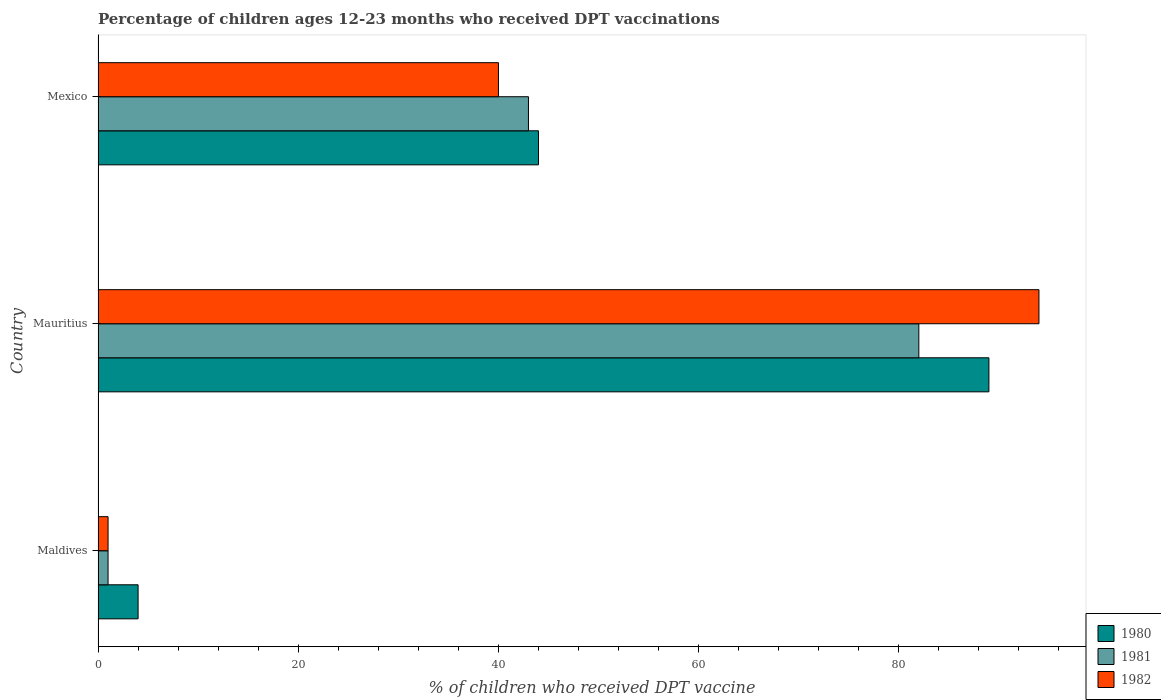How many different coloured bars are there?
Your answer should be compact. 3. How many groups of bars are there?
Keep it short and to the point. 3. Are the number of bars on each tick of the Y-axis equal?
Keep it short and to the point. Yes. How many bars are there on the 1st tick from the bottom?
Offer a terse response. 3. What is the label of the 2nd group of bars from the top?
Your response must be concise. Mauritius. What is the percentage of children who received DPT vaccination in 1980 in Mauritius?
Provide a succinct answer. 89. Across all countries, what is the minimum percentage of children who received DPT vaccination in 1982?
Your answer should be very brief. 1. In which country was the percentage of children who received DPT vaccination in 1981 maximum?
Your answer should be very brief. Mauritius. In which country was the percentage of children who received DPT vaccination in 1981 minimum?
Ensure brevity in your answer.  Maldives. What is the total percentage of children who received DPT vaccination in 1982 in the graph?
Your answer should be compact. 135. What is the difference between the percentage of children who received DPT vaccination in 1982 in Mauritius and that in Mexico?
Make the answer very short. 54. What is the difference between the percentage of children who received DPT vaccination in 1981 in Mauritius and the percentage of children who received DPT vaccination in 1982 in Maldives?
Give a very brief answer. 81. What is the average percentage of children who received DPT vaccination in 1980 per country?
Ensure brevity in your answer.  45.67. In how many countries, is the percentage of children who received DPT vaccination in 1982 greater than 52 %?
Provide a short and direct response. 1. What is the ratio of the percentage of children who received DPT vaccination in 1982 in Mauritius to that in Mexico?
Give a very brief answer. 2.35. Is the percentage of children who received DPT vaccination in 1982 in Maldives less than that in Mauritius?
Your answer should be very brief. Yes. What is the difference between the highest and the second highest percentage of children who received DPT vaccination in 1981?
Your answer should be very brief. 39. In how many countries, is the percentage of children who received DPT vaccination in 1980 greater than the average percentage of children who received DPT vaccination in 1980 taken over all countries?
Provide a short and direct response. 1. Is the sum of the percentage of children who received DPT vaccination in 1980 in Mauritius and Mexico greater than the maximum percentage of children who received DPT vaccination in 1981 across all countries?
Make the answer very short. Yes. What does the 2nd bar from the top in Mexico represents?
Offer a terse response. 1981. How many bars are there?
Give a very brief answer. 9. What is the difference between two consecutive major ticks on the X-axis?
Your response must be concise. 20. Does the graph contain any zero values?
Provide a succinct answer. No. Where does the legend appear in the graph?
Offer a terse response. Bottom right. How many legend labels are there?
Ensure brevity in your answer.  3. How are the legend labels stacked?
Give a very brief answer. Vertical. What is the title of the graph?
Provide a short and direct response. Percentage of children ages 12-23 months who received DPT vaccinations. What is the label or title of the X-axis?
Offer a terse response. % of children who received DPT vaccine. What is the % of children who received DPT vaccine of 1980 in Maldives?
Your answer should be compact. 4. What is the % of children who received DPT vaccine in 1980 in Mauritius?
Offer a very short reply. 89. What is the % of children who received DPT vaccine of 1981 in Mauritius?
Offer a very short reply. 82. What is the % of children who received DPT vaccine of 1982 in Mauritius?
Provide a succinct answer. 94. What is the % of children who received DPT vaccine in 1982 in Mexico?
Offer a terse response. 40. Across all countries, what is the maximum % of children who received DPT vaccine in 1980?
Ensure brevity in your answer.  89. Across all countries, what is the maximum % of children who received DPT vaccine of 1981?
Keep it short and to the point. 82. Across all countries, what is the maximum % of children who received DPT vaccine of 1982?
Give a very brief answer. 94. Across all countries, what is the minimum % of children who received DPT vaccine in 1981?
Your answer should be very brief. 1. Across all countries, what is the minimum % of children who received DPT vaccine of 1982?
Give a very brief answer. 1. What is the total % of children who received DPT vaccine in 1980 in the graph?
Give a very brief answer. 137. What is the total % of children who received DPT vaccine of 1981 in the graph?
Your response must be concise. 126. What is the total % of children who received DPT vaccine of 1982 in the graph?
Your answer should be very brief. 135. What is the difference between the % of children who received DPT vaccine of 1980 in Maldives and that in Mauritius?
Your response must be concise. -85. What is the difference between the % of children who received DPT vaccine of 1981 in Maldives and that in Mauritius?
Give a very brief answer. -81. What is the difference between the % of children who received DPT vaccine of 1982 in Maldives and that in Mauritius?
Your answer should be compact. -93. What is the difference between the % of children who received DPT vaccine of 1981 in Maldives and that in Mexico?
Offer a very short reply. -42. What is the difference between the % of children who received DPT vaccine of 1982 in Maldives and that in Mexico?
Your answer should be compact. -39. What is the difference between the % of children who received DPT vaccine in 1980 in Mauritius and that in Mexico?
Provide a short and direct response. 45. What is the difference between the % of children who received DPT vaccine in 1982 in Mauritius and that in Mexico?
Make the answer very short. 54. What is the difference between the % of children who received DPT vaccine of 1980 in Maldives and the % of children who received DPT vaccine of 1981 in Mauritius?
Offer a terse response. -78. What is the difference between the % of children who received DPT vaccine of 1980 in Maldives and the % of children who received DPT vaccine of 1982 in Mauritius?
Make the answer very short. -90. What is the difference between the % of children who received DPT vaccine in 1981 in Maldives and the % of children who received DPT vaccine in 1982 in Mauritius?
Offer a terse response. -93. What is the difference between the % of children who received DPT vaccine in 1980 in Maldives and the % of children who received DPT vaccine in 1981 in Mexico?
Your answer should be compact. -39. What is the difference between the % of children who received DPT vaccine in 1980 in Maldives and the % of children who received DPT vaccine in 1982 in Mexico?
Offer a very short reply. -36. What is the difference between the % of children who received DPT vaccine in 1981 in Maldives and the % of children who received DPT vaccine in 1982 in Mexico?
Keep it short and to the point. -39. What is the average % of children who received DPT vaccine of 1980 per country?
Provide a short and direct response. 45.67. What is the average % of children who received DPT vaccine in 1982 per country?
Keep it short and to the point. 45. What is the difference between the % of children who received DPT vaccine in 1981 and % of children who received DPT vaccine in 1982 in Maldives?
Offer a very short reply. 0. What is the difference between the % of children who received DPT vaccine of 1980 and % of children who received DPT vaccine of 1982 in Mauritius?
Make the answer very short. -5. What is the difference between the % of children who received DPT vaccine of 1981 and % of children who received DPT vaccine of 1982 in Mauritius?
Make the answer very short. -12. What is the difference between the % of children who received DPT vaccine of 1980 and % of children who received DPT vaccine of 1981 in Mexico?
Your answer should be very brief. 1. What is the difference between the % of children who received DPT vaccine of 1980 and % of children who received DPT vaccine of 1982 in Mexico?
Make the answer very short. 4. What is the ratio of the % of children who received DPT vaccine of 1980 in Maldives to that in Mauritius?
Make the answer very short. 0.04. What is the ratio of the % of children who received DPT vaccine of 1981 in Maldives to that in Mauritius?
Keep it short and to the point. 0.01. What is the ratio of the % of children who received DPT vaccine in 1982 in Maldives to that in Mauritius?
Provide a succinct answer. 0.01. What is the ratio of the % of children who received DPT vaccine of 1980 in Maldives to that in Mexico?
Ensure brevity in your answer.  0.09. What is the ratio of the % of children who received DPT vaccine in 1981 in Maldives to that in Mexico?
Your response must be concise. 0.02. What is the ratio of the % of children who received DPT vaccine of 1982 in Maldives to that in Mexico?
Your response must be concise. 0.03. What is the ratio of the % of children who received DPT vaccine in 1980 in Mauritius to that in Mexico?
Your answer should be very brief. 2.02. What is the ratio of the % of children who received DPT vaccine of 1981 in Mauritius to that in Mexico?
Provide a succinct answer. 1.91. What is the ratio of the % of children who received DPT vaccine of 1982 in Mauritius to that in Mexico?
Give a very brief answer. 2.35. What is the difference between the highest and the second highest % of children who received DPT vaccine of 1980?
Ensure brevity in your answer.  45. What is the difference between the highest and the second highest % of children who received DPT vaccine in 1982?
Offer a very short reply. 54. What is the difference between the highest and the lowest % of children who received DPT vaccine of 1982?
Offer a terse response. 93. 